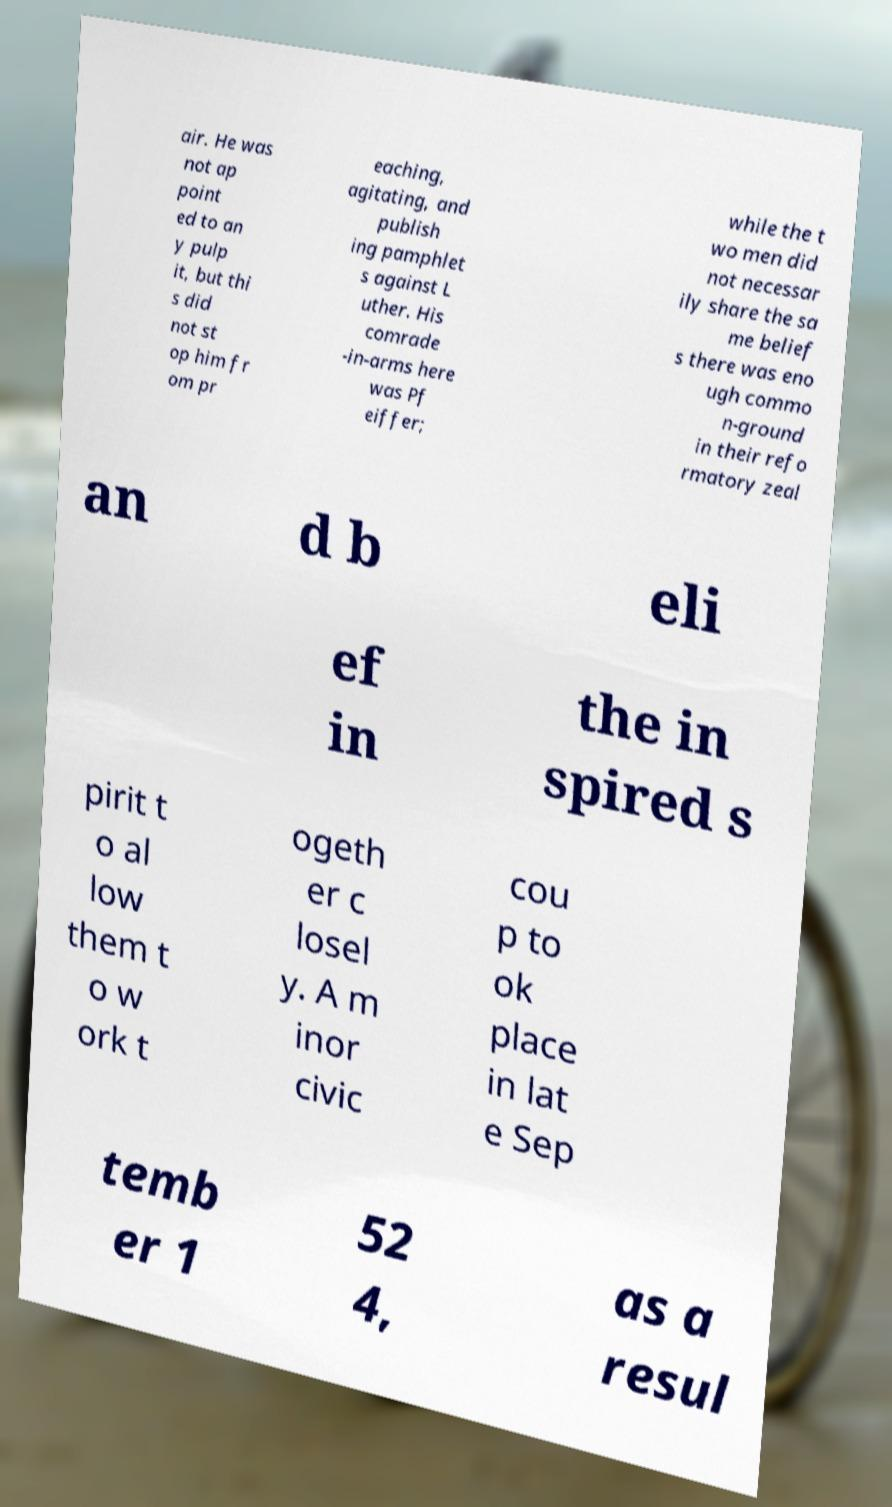Can you read and provide the text displayed in the image?This photo seems to have some interesting text. Can you extract and type it out for me? air. He was not ap point ed to an y pulp it, but thi s did not st op him fr om pr eaching, agitating, and publish ing pamphlet s against L uther. His comrade -in-arms here was Pf eiffer; while the t wo men did not necessar ily share the sa me belief s there was eno ugh commo n-ground in their refo rmatory zeal an d b eli ef in the in spired s pirit t o al low them t o w ork t ogeth er c losel y. A m inor civic cou p to ok place in lat e Sep temb er 1 52 4, as a resul 